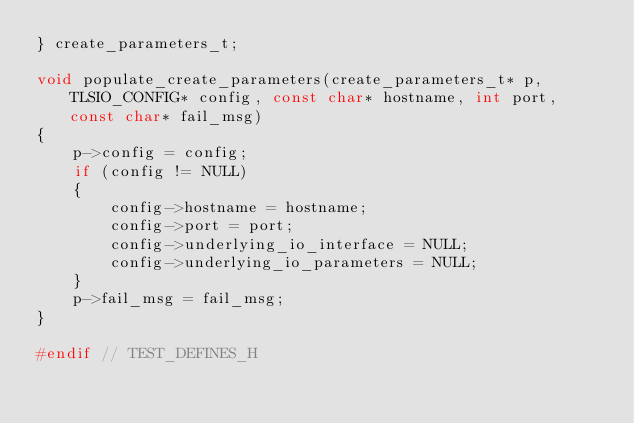Convert code to text. <code><loc_0><loc_0><loc_500><loc_500><_C_>} create_parameters_t;

void populate_create_parameters(create_parameters_t* p, TLSIO_CONFIG* config, const char* hostname, int port, const char* fail_msg)
{
    p->config = config;
    if (config != NULL)
    {
        config->hostname = hostname;
        config->port = port;
        config->underlying_io_interface = NULL;
        config->underlying_io_parameters = NULL;
    }
    p->fail_msg = fail_msg;
}

#endif // TEST_DEFINES_H
</code> 